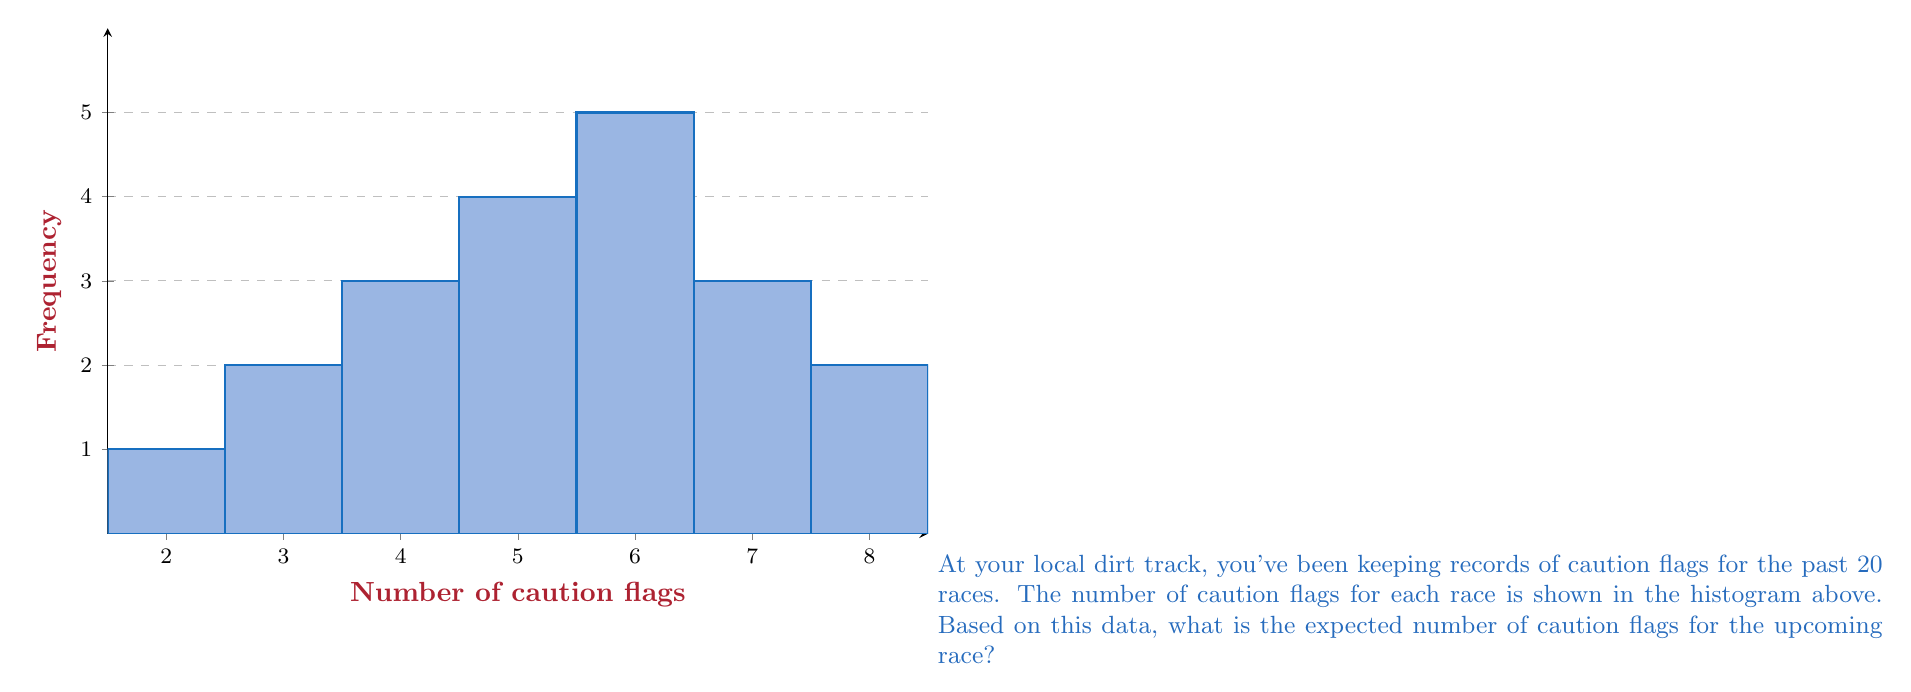Could you help me with this problem? To find the expected number of caution flags, we need to calculate the mean of the given data. Let's approach this step-by-step:

1) First, let's organize the data into a frequency table:

   Caution Flags (x) | Frequency (f)
   2                 | 1
   3                 | 2
   4                 | 3
   5                 | 4
   6                 | 5
   7                 | 2
   8                 | 2
   9                 | 1

2) To calculate the mean, we use the formula:

   $$ \text{Mean} = \frac{\sum_{i=1}^{n} x_i f_i}{\sum_{i=1}^{n} f_i} $$

   Where $x_i$ is each unique value and $f_i$ is its frequency.

3) Let's calculate $\sum x_i f_i$:

   $$ (2 \cdot 1) + (3 \cdot 2) + (4 \cdot 3) + (5 \cdot 4) + (6 \cdot 5) + (7 \cdot 2) + (8 \cdot 2) + (9 \cdot 1) $$
   $$ = 2 + 6 + 12 + 20 + 30 + 14 + 16 + 9 = 109 $$

4) The total number of races (sum of frequencies) is 20.

5) Now we can calculate the mean:

   $$ \text{Mean} = \frac{109}{20} = 5.45 $$

Therefore, based on the historical data, the expected number of caution flags for the upcoming race is 5.45.
Answer: 5.45 caution flags 